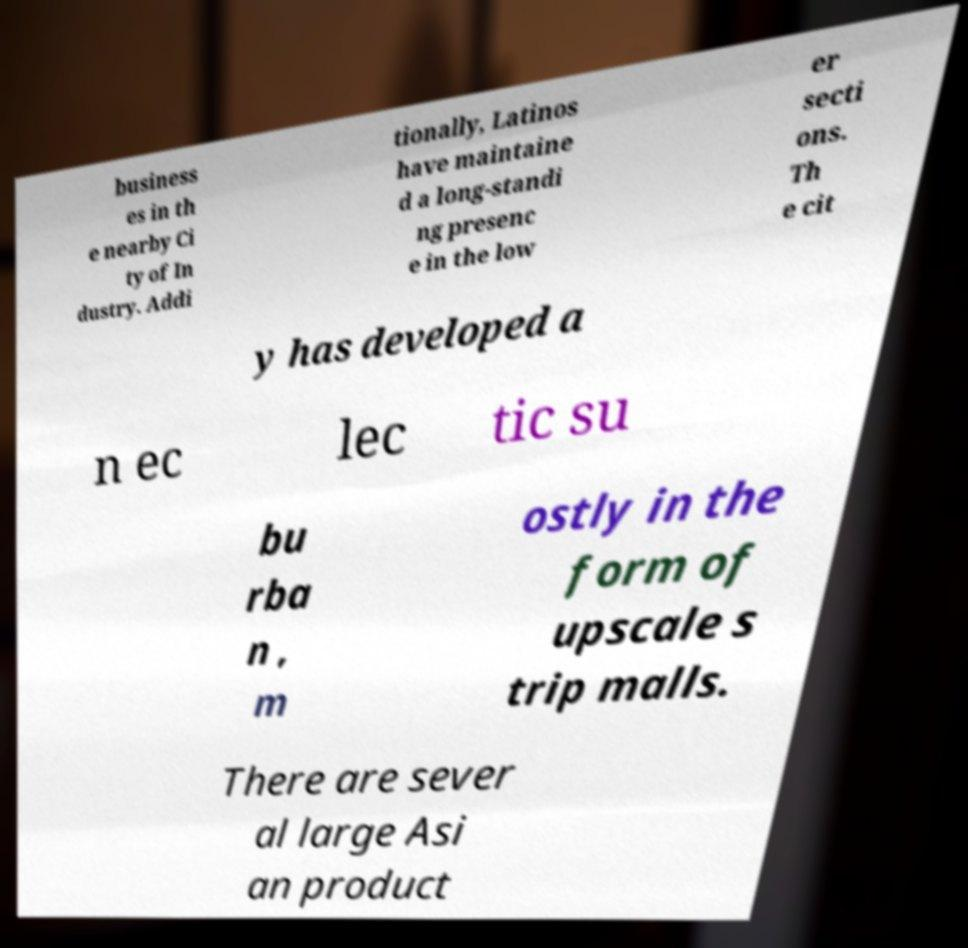Can you accurately transcribe the text from the provided image for me? business es in th e nearby Ci ty of In dustry. Addi tionally, Latinos have maintaine d a long-standi ng presenc e in the low er secti ons. Th e cit y has developed a n ec lec tic su bu rba n , m ostly in the form of upscale s trip malls. There are sever al large Asi an product 